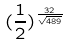Convert formula to latex. <formula><loc_0><loc_0><loc_500><loc_500>( \frac { 1 } { 2 } ) ^ { \frac { 3 2 } { \sqrt { 4 8 9 } } }</formula> 